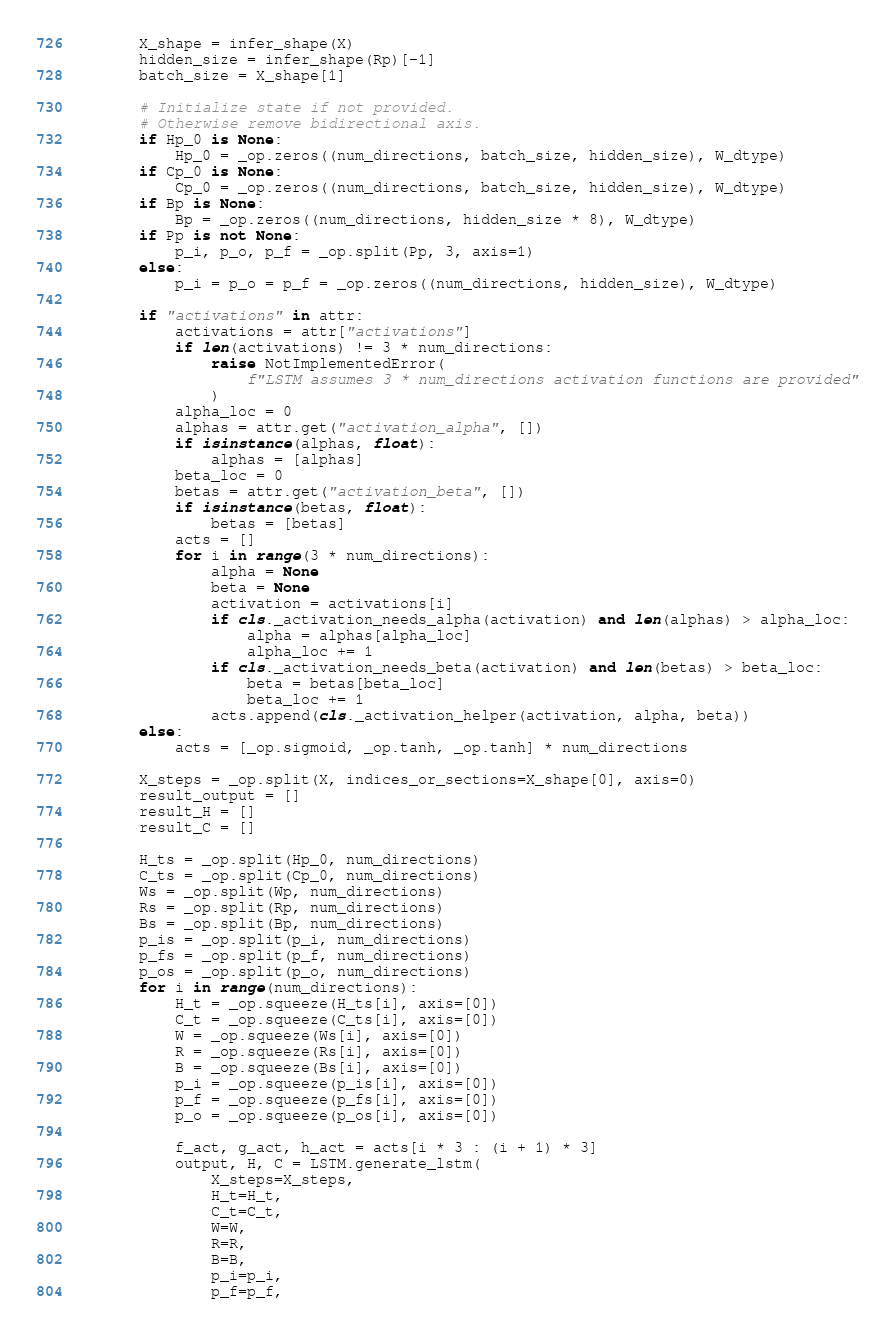Convert code to text. <code><loc_0><loc_0><loc_500><loc_500><_Python_>        X_shape = infer_shape(X)
        hidden_size = infer_shape(Rp)[-1]
        batch_size = X_shape[1]

        # Initialize state if not provided.
        # Otherwise remove bidirectional axis.
        if Hp_0 is None:
            Hp_0 = _op.zeros((num_directions, batch_size, hidden_size), W_dtype)
        if Cp_0 is None:
            Cp_0 = _op.zeros((num_directions, batch_size, hidden_size), W_dtype)
        if Bp is None:
            Bp = _op.zeros((num_directions, hidden_size * 8), W_dtype)
        if Pp is not None:
            p_i, p_o, p_f = _op.split(Pp, 3, axis=1)
        else:
            p_i = p_o = p_f = _op.zeros((num_directions, hidden_size), W_dtype)

        if "activations" in attr:
            activations = attr["activations"]
            if len(activations) != 3 * num_directions:
                raise NotImplementedError(
                    f"LSTM assumes 3 * num_directions activation functions are provided"
                )
            alpha_loc = 0
            alphas = attr.get("activation_alpha", [])
            if isinstance(alphas, float):
                alphas = [alphas]
            beta_loc = 0
            betas = attr.get("activation_beta", [])
            if isinstance(betas, float):
                betas = [betas]
            acts = []
            for i in range(3 * num_directions):
                alpha = None
                beta = None
                activation = activations[i]
                if cls._activation_needs_alpha(activation) and len(alphas) > alpha_loc:
                    alpha = alphas[alpha_loc]
                    alpha_loc += 1
                if cls._activation_needs_beta(activation) and len(betas) > beta_loc:
                    beta = betas[beta_loc]
                    beta_loc += 1
                acts.append(cls._activation_helper(activation, alpha, beta))
        else:
            acts = [_op.sigmoid, _op.tanh, _op.tanh] * num_directions

        X_steps = _op.split(X, indices_or_sections=X_shape[0], axis=0)
        result_output = []
        result_H = []
        result_C = []

        H_ts = _op.split(Hp_0, num_directions)
        C_ts = _op.split(Cp_0, num_directions)
        Ws = _op.split(Wp, num_directions)
        Rs = _op.split(Rp, num_directions)
        Bs = _op.split(Bp, num_directions)
        p_is = _op.split(p_i, num_directions)
        p_fs = _op.split(p_f, num_directions)
        p_os = _op.split(p_o, num_directions)
        for i in range(num_directions):
            H_t = _op.squeeze(H_ts[i], axis=[0])
            C_t = _op.squeeze(C_ts[i], axis=[0])
            W = _op.squeeze(Ws[i], axis=[0])
            R = _op.squeeze(Rs[i], axis=[0])
            B = _op.squeeze(Bs[i], axis=[0])
            p_i = _op.squeeze(p_is[i], axis=[0])
            p_f = _op.squeeze(p_fs[i], axis=[0])
            p_o = _op.squeeze(p_os[i], axis=[0])

            f_act, g_act, h_act = acts[i * 3 : (i + 1) * 3]
            output, H, C = LSTM.generate_lstm(
                X_steps=X_steps,
                H_t=H_t,
                C_t=C_t,
                W=W,
                R=R,
                B=B,
                p_i=p_i,
                p_f=p_f,</code> 